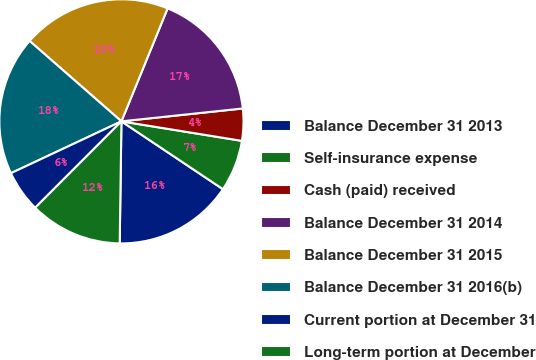<chart> <loc_0><loc_0><loc_500><loc_500><pie_chart><fcel>Balance December 31 2013<fcel>Self-insurance expense<fcel>Cash (paid) received<fcel>Balance December 31 2014<fcel>Balance December 31 2015<fcel>Balance December 31 2016(b)<fcel>Current portion at December 31<fcel>Long-term portion at December<nl><fcel>15.85%<fcel>6.82%<fcel>4.24%<fcel>17.14%<fcel>19.73%<fcel>18.43%<fcel>5.53%<fcel>12.26%<nl></chart> 